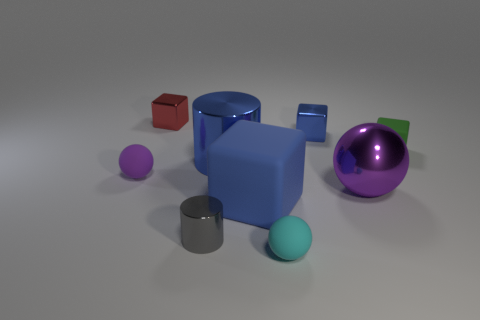Add 1 gray matte spheres. How many objects exist? 10 Subtract all spheres. How many objects are left? 6 Add 5 red shiny blocks. How many red shiny blocks are left? 6 Add 3 cyan things. How many cyan things exist? 4 Subtract 0 brown cylinders. How many objects are left? 9 Subtract all cyan shiny things. Subtract all matte objects. How many objects are left? 5 